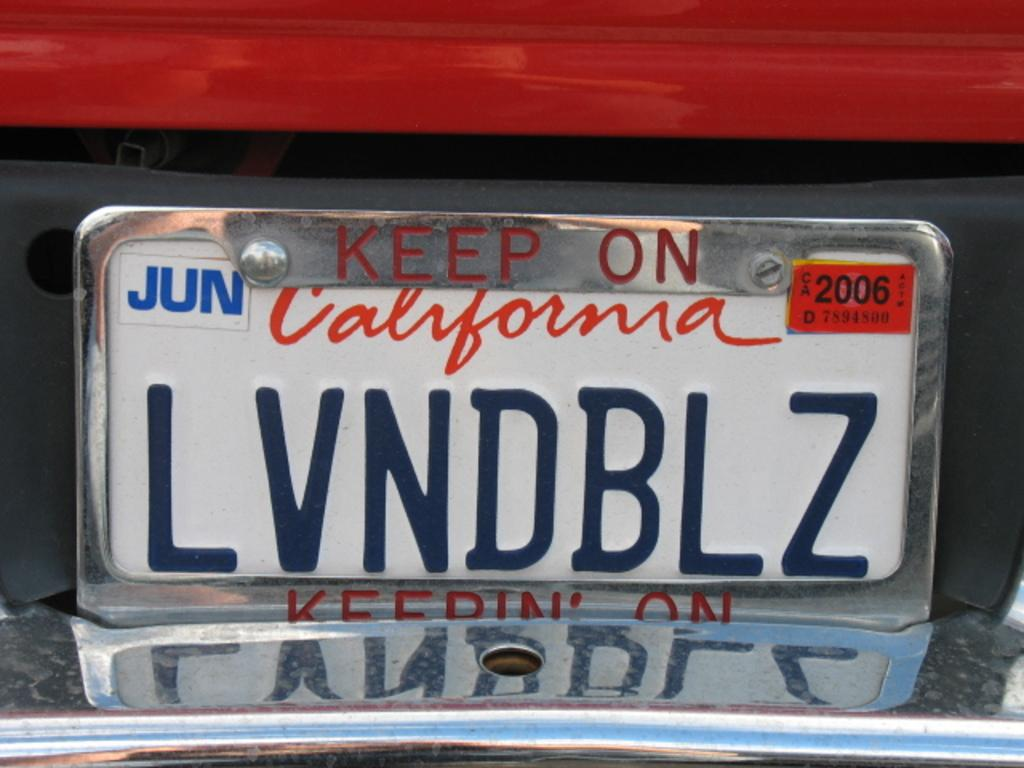<image>
Render a clear and concise summary of the photo. The California licence plate shows it runs out in Jun 2006. 